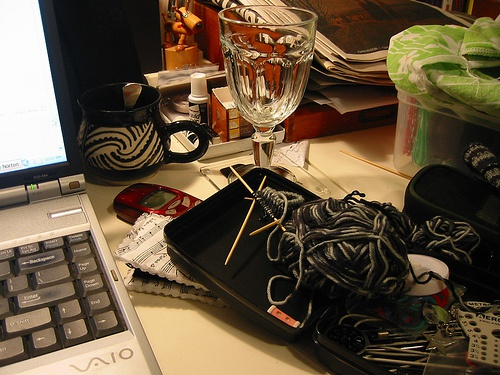Describe the objects in this image and their specific colors. I can see laptop in white, black, tan, and gray tones, wine glass in white, maroon, and tan tones, cup in white, black, olive, and maroon tones, and cell phone in white, black, maroon, and olive tones in this image. 